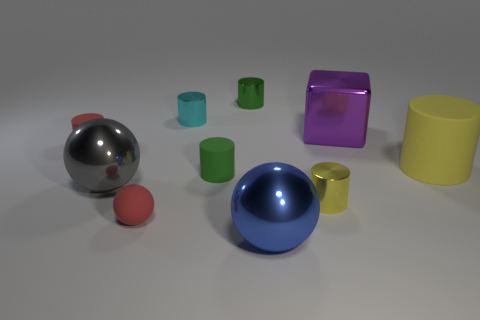Does the big gray ball have the same material as the purple block?
Keep it short and to the point. Yes. There is a large metallic thing that is behind the gray metal sphere that is left of the red thing that is in front of the tiny yellow metal object; what color is it?
Give a very brief answer. Purple. What number of things are either cylinders that are behind the big purple object or small cylinders?
Provide a short and direct response. 5. There is a sphere that is the same size as the cyan shiny thing; what is its material?
Offer a very short reply. Rubber. The tiny green thing to the left of the green cylinder that is behind the small red object behind the large yellow rubber cylinder is made of what material?
Keep it short and to the point. Rubber. The large metal block has what color?
Provide a succinct answer. Purple. What number of tiny things are green metallic cylinders or cylinders?
Your response must be concise. 5. What is the material of the other cylinder that is the same color as the big cylinder?
Offer a very short reply. Metal. Do the yellow thing that is to the left of the large rubber cylinder and the large sphere that is left of the blue ball have the same material?
Give a very brief answer. Yes. Is there a small matte cylinder?
Keep it short and to the point. Yes. 